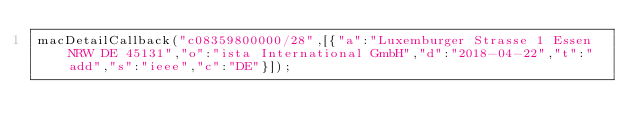<code> <loc_0><loc_0><loc_500><loc_500><_JavaScript_>macDetailCallback("c08359800000/28",[{"a":"Luxemburger Strasse 1 Essen NRW DE 45131","o":"ista International GmbH","d":"2018-04-22","t":"add","s":"ieee","c":"DE"}]);
</code> 